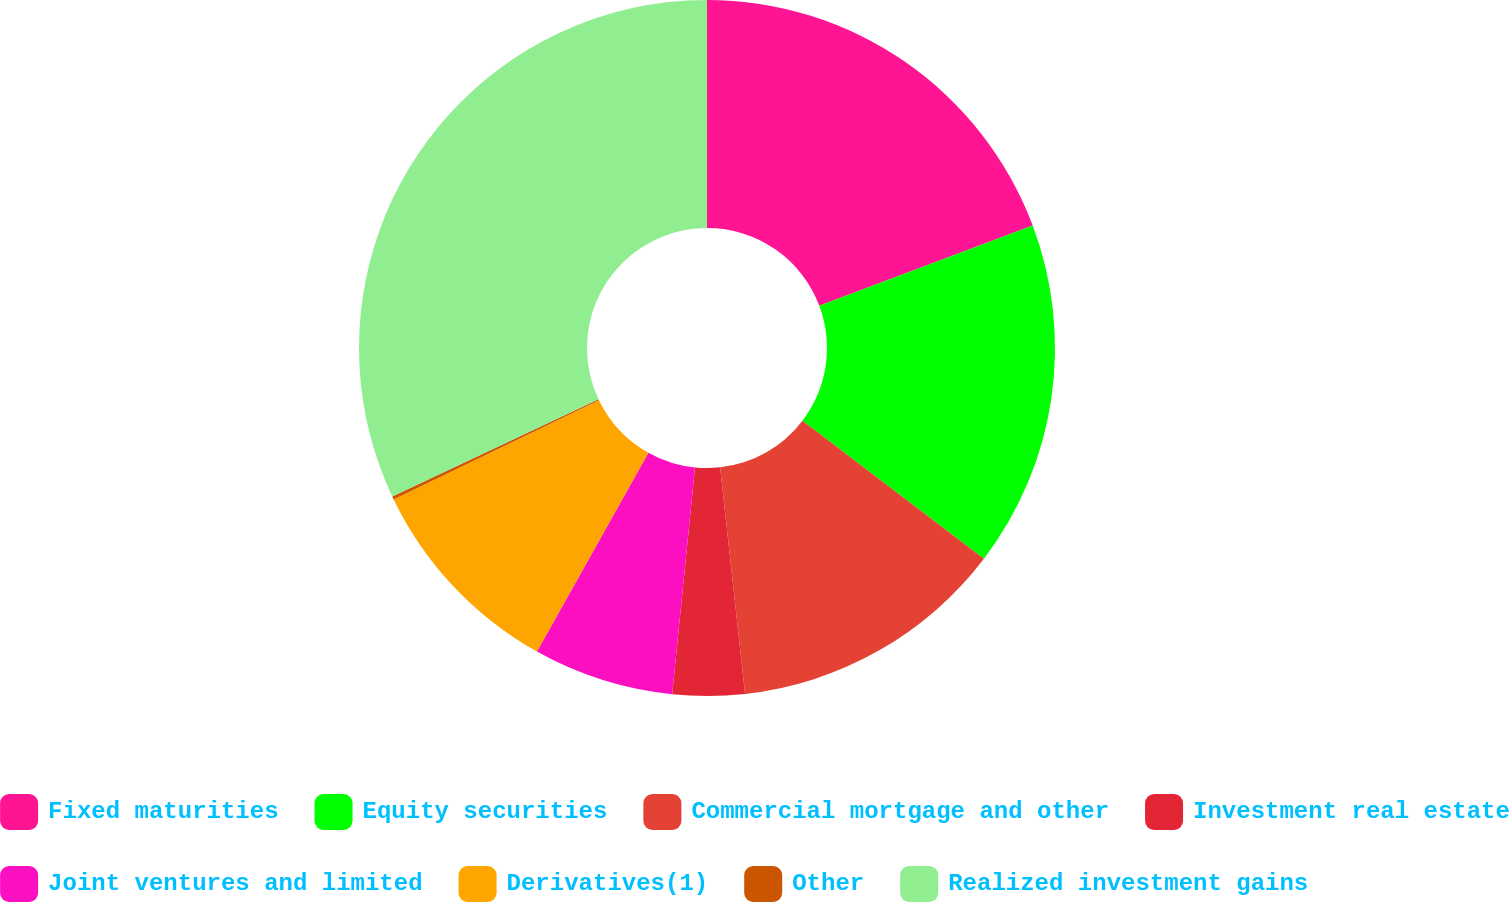<chart> <loc_0><loc_0><loc_500><loc_500><pie_chart><fcel>Fixed maturities<fcel>Equity securities<fcel>Commercial mortgage and other<fcel>Investment real estate<fcel>Joint ventures and limited<fcel>Derivatives(1)<fcel>Other<fcel>Realized investment gains<nl><fcel>19.27%<fcel>16.08%<fcel>12.9%<fcel>3.34%<fcel>6.53%<fcel>9.71%<fcel>0.15%<fcel>32.01%<nl></chart> 